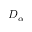Convert formula to latex. <formula><loc_0><loc_0><loc_500><loc_500>D _ { \alpha }</formula> 